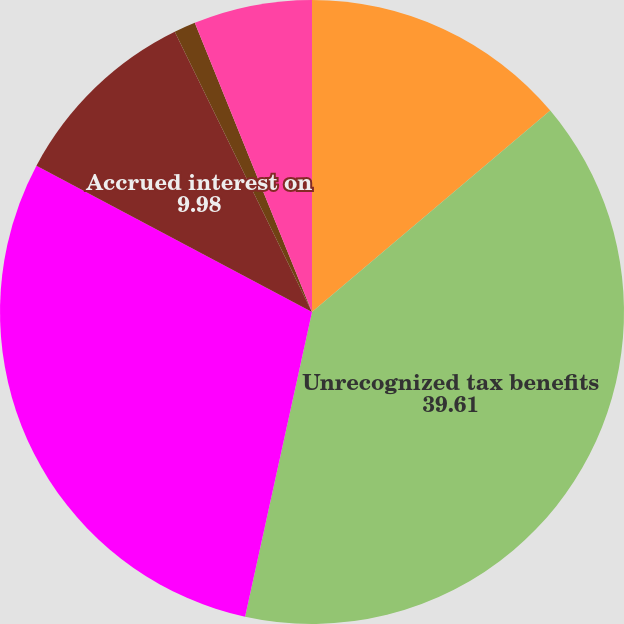Convert chart to OTSL. <chart><loc_0><loc_0><loc_500><loc_500><pie_chart><fcel>December 31 (In millions)<fcel>Unrecognized tax benefits<fcel>Portion that if recognized<fcel>Accrued interest on<fcel>Accrued penalties on<fcel>Reasonably possible reduction<nl><fcel>13.83%<fcel>39.61%<fcel>29.33%<fcel>9.98%<fcel>1.12%<fcel>6.13%<nl></chart> 